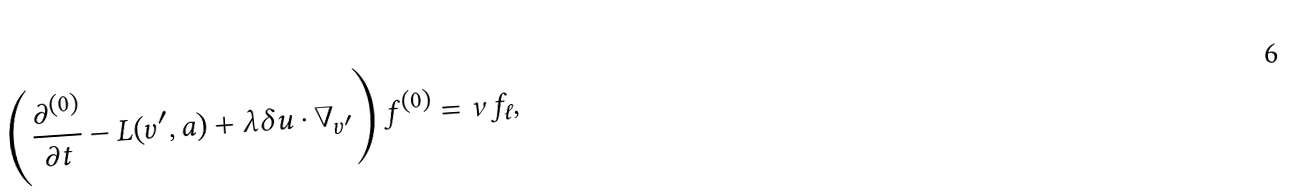Convert formula to latex. <formula><loc_0><loc_0><loc_500><loc_500>\left ( \frac { \partial ^ { ( 0 ) } } { \partial t } - L ( v ^ { \prime } , a ) + \lambda \delta { u } \cdot { \nabla } _ { { v } ^ { \prime } } \right ) f ^ { ( 0 ) } = \nu f _ { \ell } ,</formula> 